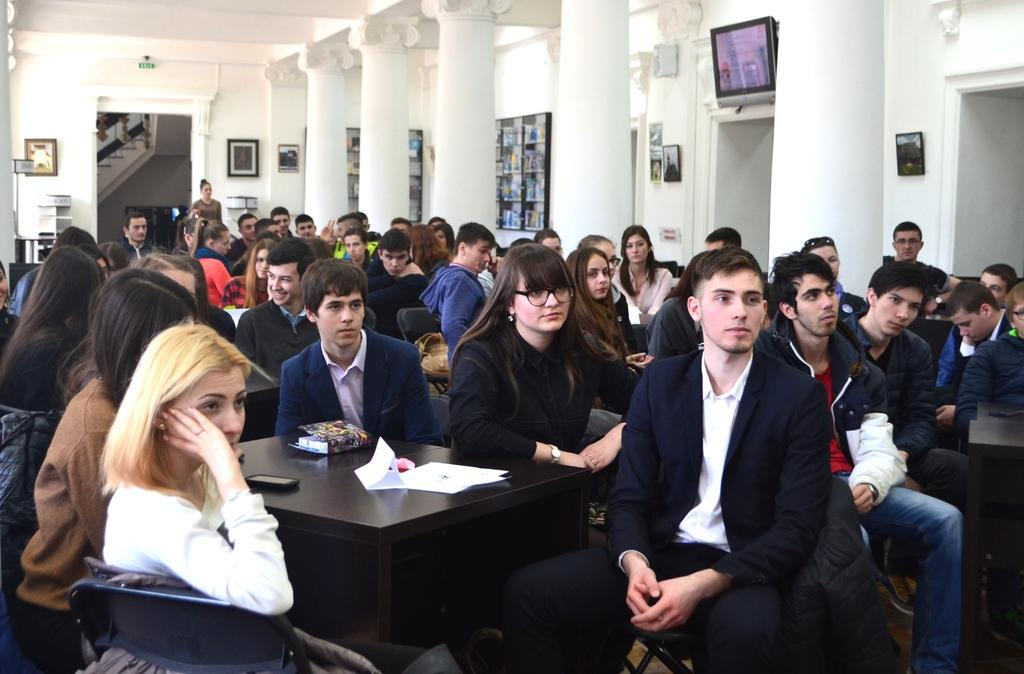What is happening in the image? There is a group of people in the image. How are the people positioned in the image? The people are sitting in chairs. What is in front of the people? There is a black table in front of the people. What color are the walls in the background? The background walls are white in color. What type of lettuce is being served on the black table in the image? There is no lettuce present in the image; the black table is in front of the people who are sitting in chairs. 